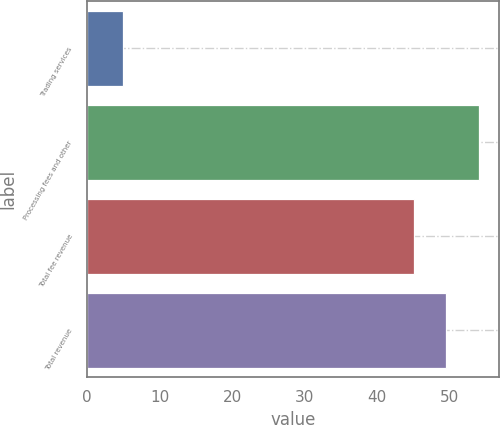<chart> <loc_0><loc_0><loc_500><loc_500><bar_chart><fcel>Trading services<fcel>Processing fees and other<fcel>Total fee revenue<fcel>Total revenue<nl><fcel>5<fcel>54<fcel>45<fcel>49.5<nl></chart> 